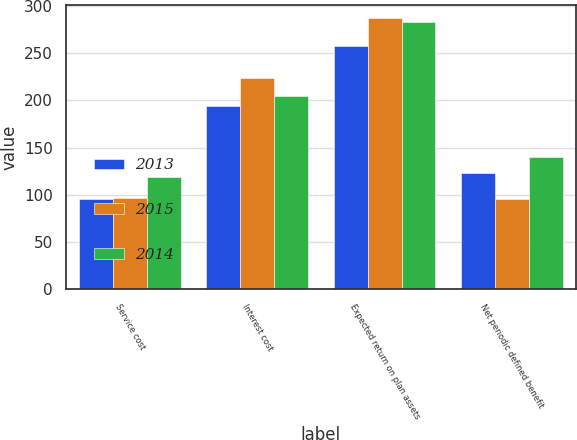<chart> <loc_0><loc_0><loc_500><loc_500><stacked_bar_chart><ecel><fcel>Service cost<fcel>Interest cost<fcel>Expected return on plan assets<fcel>Net periodic defined benefit<nl><fcel>2013<fcel>96<fcel>194<fcel>258<fcel>123<nl><fcel>2015<fcel>97<fcel>224<fcel>287<fcel>95<nl><fcel>2014<fcel>119<fcel>205<fcel>283<fcel>140<nl></chart> 